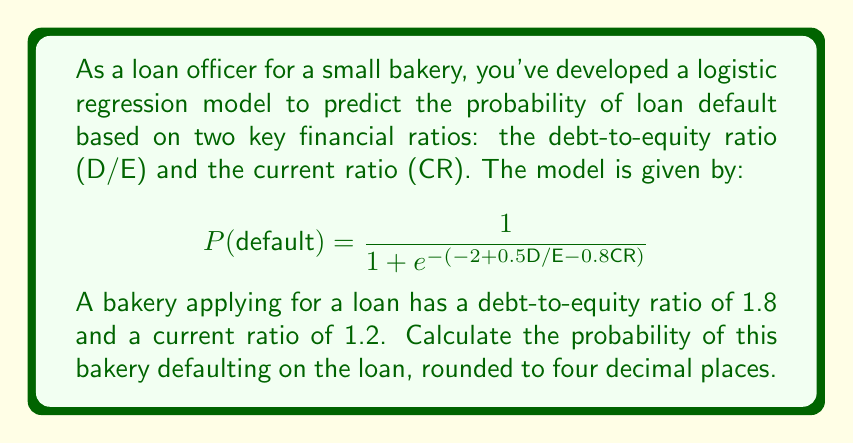Can you solve this math problem? To solve this problem, we'll follow these steps:

1. Identify the given values:
   D/E (debt-to-equity ratio) = 1.8
   CR (current ratio) = 1.2

2. Substitute these values into the logistic regression equation:

   $$P(\text{default}) = \frac{1}{1 + e^{-(-2 + 0.5\text{D/E} - 0.8\text{CR})}}$$

   $$P(\text{default}) = \frac{1}{1 + e^{-(-2 + 0.5(1.8) - 0.8(1.2))}}$$

3. Simplify the expression inside the exponential:
   
   $$-2 + 0.5(1.8) - 0.8(1.2) = -2 + 0.9 - 0.96 = -2.06$$

4. Calculate the exponential term:

   $$e^{2.06} \approx 7.8461$$

5. Substitute this value back into the equation:

   $$P(\text{default}) = \frac{1}{1 + 7.8461}$$

6. Perform the final calculation:

   $$P(\text{default}) = \frac{1}{8.8461} \approx 0.1130$$

7. Round to four decimal places:

   $$P(\text{default}) \approx 0.1130$$
Answer: The probability of the bakery defaulting on the loan is 0.1130 or 11.30%. 